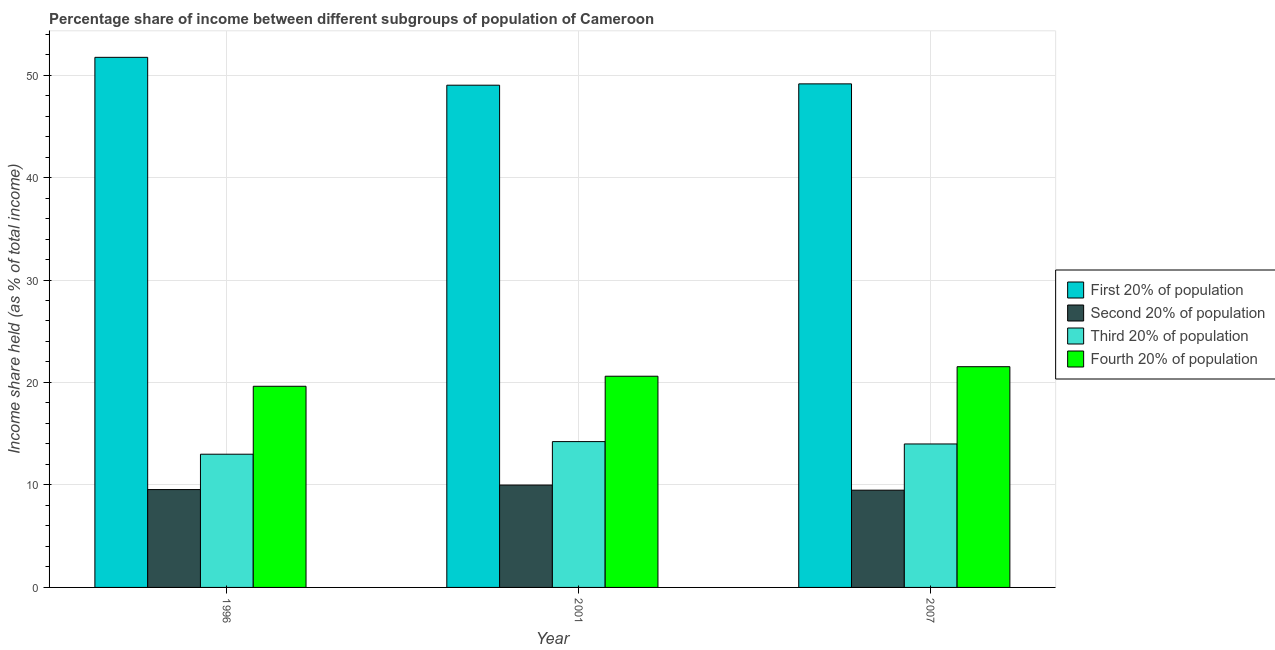How many different coloured bars are there?
Offer a very short reply. 4. Are the number of bars per tick equal to the number of legend labels?
Make the answer very short. Yes. Are the number of bars on each tick of the X-axis equal?
Make the answer very short. Yes. How many bars are there on the 3rd tick from the left?
Your answer should be compact. 4. How many bars are there on the 2nd tick from the right?
Ensure brevity in your answer.  4. What is the share of the income held by second 20% of the population in 2007?
Your response must be concise. 9.49. Across all years, what is the maximum share of the income held by second 20% of the population?
Your response must be concise. 9.99. Across all years, what is the minimum share of the income held by second 20% of the population?
Offer a very short reply. 9.49. What is the total share of the income held by first 20% of the population in the graph?
Ensure brevity in your answer.  149.88. What is the difference between the share of the income held by fourth 20% of the population in 2001 and that in 2007?
Make the answer very short. -0.93. What is the difference between the share of the income held by fourth 20% of the population in 2007 and the share of the income held by first 20% of the population in 2001?
Offer a terse response. 0.93. What is the average share of the income held by second 20% of the population per year?
Provide a succinct answer. 9.68. In the year 2001, what is the difference between the share of the income held by third 20% of the population and share of the income held by fourth 20% of the population?
Make the answer very short. 0. What is the ratio of the share of the income held by first 20% of the population in 1996 to that in 2001?
Make the answer very short. 1.06. What is the difference between the highest and the second highest share of the income held by third 20% of the population?
Offer a very short reply. 0.23. What is the difference between the highest and the lowest share of the income held by second 20% of the population?
Your answer should be compact. 0.5. Is the sum of the share of the income held by fourth 20% of the population in 1996 and 2001 greater than the maximum share of the income held by first 20% of the population across all years?
Give a very brief answer. Yes. Is it the case that in every year, the sum of the share of the income held by second 20% of the population and share of the income held by third 20% of the population is greater than the sum of share of the income held by first 20% of the population and share of the income held by fourth 20% of the population?
Provide a short and direct response. No. What does the 3rd bar from the left in 1996 represents?
Your response must be concise. Third 20% of population. What does the 3rd bar from the right in 2001 represents?
Your response must be concise. Second 20% of population. How many years are there in the graph?
Provide a short and direct response. 3. What is the difference between two consecutive major ticks on the Y-axis?
Your response must be concise. 10. Are the values on the major ticks of Y-axis written in scientific E-notation?
Your answer should be compact. No. Does the graph contain any zero values?
Offer a very short reply. No. How many legend labels are there?
Ensure brevity in your answer.  4. How are the legend labels stacked?
Provide a short and direct response. Vertical. What is the title of the graph?
Give a very brief answer. Percentage share of income between different subgroups of population of Cameroon. Does "Australia" appear as one of the legend labels in the graph?
Ensure brevity in your answer.  No. What is the label or title of the Y-axis?
Ensure brevity in your answer.  Income share held (as % of total income). What is the Income share held (as % of total income) of First 20% of population in 1996?
Keep it short and to the point. 51.73. What is the Income share held (as % of total income) in Second 20% of population in 1996?
Your response must be concise. 9.55. What is the Income share held (as % of total income) of Third 20% of population in 1996?
Your answer should be compact. 13. What is the Income share held (as % of total income) in Fourth 20% of population in 1996?
Ensure brevity in your answer.  19.63. What is the Income share held (as % of total income) in First 20% of population in 2001?
Your answer should be compact. 49.01. What is the Income share held (as % of total income) of Second 20% of population in 2001?
Offer a very short reply. 9.99. What is the Income share held (as % of total income) in Third 20% of population in 2001?
Provide a short and direct response. 14.23. What is the Income share held (as % of total income) of Fourth 20% of population in 2001?
Ensure brevity in your answer.  20.61. What is the Income share held (as % of total income) of First 20% of population in 2007?
Offer a terse response. 49.14. What is the Income share held (as % of total income) in Second 20% of population in 2007?
Offer a very short reply. 9.49. What is the Income share held (as % of total income) of Fourth 20% of population in 2007?
Your answer should be very brief. 21.54. Across all years, what is the maximum Income share held (as % of total income) in First 20% of population?
Make the answer very short. 51.73. Across all years, what is the maximum Income share held (as % of total income) in Second 20% of population?
Your response must be concise. 9.99. Across all years, what is the maximum Income share held (as % of total income) in Third 20% of population?
Your response must be concise. 14.23. Across all years, what is the maximum Income share held (as % of total income) of Fourth 20% of population?
Your response must be concise. 21.54. Across all years, what is the minimum Income share held (as % of total income) in First 20% of population?
Provide a succinct answer. 49.01. Across all years, what is the minimum Income share held (as % of total income) in Second 20% of population?
Make the answer very short. 9.49. Across all years, what is the minimum Income share held (as % of total income) in Third 20% of population?
Provide a succinct answer. 13. Across all years, what is the minimum Income share held (as % of total income) in Fourth 20% of population?
Your answer should be very brief. 19.63. What is the total Income share held (as % of total income) of First 20% of population in the graph?
Ensure brevity in your answer.  149.88. What is the total Income share held (as % of total income) in Second 20% of population in the graph?
Offer a terse response. 29.03. What is the total Income share held (as % of total income) in Third 20% of population in the graph?
Offer a very short reply. 41.23. What is the total Income share held (as % of total income) of Fourth 20% of population in the graph?
Your answer should be very brief. 61.78. What is the difference between the Income share held (as % of total income) of First 20% of population in 1996 and that in 2001?
Offer a terse response. 2.72. What is the difference between the Income share held (as % of total income) in Second 20% of population in 1996 and that in 2001?
Give a very brief answer. -0.44. What is the difference between the Income share held (as % of total income) in Third 20% of population in 1996 and that in 2001?
Offer a terse response. -1.23. What is the difference between the Income share held (as % of total income) of Fourth 20% of population in 1996 and that in 2001?
Your response must be concise. -0.98. What is the difference between the Income share held (as % of total income) in First 20% of population in 1996 and that in 2007?
Ensure brevity in your answer.  2.59. What is the difference between the Income share held (as % of total income) of Second 20% of population in 1996 and that in 2007?
Provide a succinct answer. 0.06. What is the difference between the Income share held (as % of total income) of Fourth 20% of population in 1996 and that in 2007?
Your answer should be very brief. -1.91. What is the difference between the Income share held (as % of total income) in First 20% of population in 2001 and that in 2007?
Offer a terse response. -0.13. What is the difference between the Income share held (as % of total income) of Second 20% of population in 2001 and that in 2007?
Provide a succinct answer. 0.5. What is the difference between the Income share held (as % of total income) of Third 20% of population in 2001 and that in 2007?
Offer a very short reply. 0.23. What is the difference between the Income share held (as % of total income) in Fourth 20% of population in 2001 and that in 2007?
Give a very brief answer. -0.93. What is the difference between the Income share held (as % of total income) of First 20% of population in 1996 and the Income share held (as % of total income) of Second 20% of population in 2001?
Provide a succinct answer. 41.74. What is the difference between the Income share held (as % of total income) of First 20% of population in 1996 and the Income share held (as % of total income) of Third 20% of population in 2001?
Ensure brevity in your answer.  37.5. What is the difference between the Income share held (as % of total income) in First 20% of population in 1996 and the Income share held (as % of total income) in Fourth 20% of population in 2001?
Your response must be concise. 31.12. What is the difference between the Income share held (as % of total income) of Second 20% of population in 1996 and the Income share held (as % of total income) of Third 20% of population in 2001?
Your answer should be very brief. -4.68. What is the difference between the Income share held (as % of total income) of Second 20% of population in 1996 and the Income share held (as % of total income) of Fourth 20% of population in 2001?
Keep it short and to the point. -11.06. What is the difference between the Income share held (as % of total income) of Third 20% of population in 1996 and the Income share held (as % of total income) of Fourth 20% of population in 2001?
Ensure brevity in your answer.  -7.61. What is the difference between the Income share held (as % of total income) in First 20% of population in 1996 and the Income share held (as % of total income) in Second 20% of population in 2007?
Your response must be concise. 42.24. What is the difference between the Income share held (as % of total income) of First 20% of population in 1996 and the Income share held (as % of total income) of Third 20% of population in 2007?
Your response must be concise. 37.73. What is the difference between the Income share held (as % of total income) of First 20% of population in 1996 and the Income share held (as % of total income) of Fourth 20% of population in 2007?
Keep it short and to the point. 30.19. What is the difference between the Income share held (as % of total income) of Second 20% of population in 1996 and the Income share held (as % of total income) of Third 20% of population in 2007?
Your answer should be very brief. -4.45. What is the difference between the Income share held (as % of total income) in Second 20% of population in 1996 and the Income share held (as % of total income) in Fourth 20% of population in 2007?
Offer a very short reply. -11.99. What is the difference between the Income share held (as % of total income) of Third 20% of population in 1996 and the Income share held (as % of total income) of Fourth 20% of population in 2007?
Your answer should be very brief. -8.54. What is the difference between the Income share held (as % of total income) in First 20% of population in 2001 and the Income share held (as % of total income) in Second 20% of population in 2007?
Provide a succinct answer. 39.52. What is the difference between the Income share held (as % of total income) of First 20% of population in 2001 and the Income share held (as % of total income) of Third 20% of population in 2007?
Make the answer very short. 35.01. What is the difference between the Income share held (as % of total income) in First 20% of population in 2001 and the Income share held (as % of total income) in Fourth 20% of population in 2007?
Your response must be concise. 27.47. What is the difference between the Income share held (as % of total income) of Second 20% of population in 2001 and the Income share held (as % of total income) of Third 20% of population in 2007?
Provide a succinct answer. -4.01. What is the difference between the Income share held (as % of total income) in Second 20% of population in 2001 and the Income share held (as % of total income) in Fourth 20% of population in 2007?
Offer a very short reply. -11.55. What is the difference between the Income share held (as % of total income) of Third 20% of population in 2001 and the Income share held (as % of total income) of Fourth 20% of population in 2007?
Offer a terse response. -7.31. What is the average Income share held (as % of total income) of First 20% of population per year?
Provide a short and direct response. 49.96. What is the average Income share held (as % of total income) in Second 20% of population per year?
Keep it short and to the point. 9.68. What is the average Income share held (as % of total income) in Third 20% of population per year?
Keep it short and to the point. 13.74. What is the average Income share held (as % of total income) in Fourth 20% of population per year?
Your response must be concise. 20.59. In the year 1996, what is the difference between the Income share held (as % of total income) of First 20% of population and Income share held (as % of total income) of Second 20% of population?
Give a very brief answer. 42.18. In the year 1996, what is the difference between the Income share held (as % of total income) of First 20% of population and Income share held (as % of total income) of Third 20% of population?
Provide a succinct answer. 38.73. In the year 1996, what is the difference between the Income share held (as % of total income) in First 20% of population and Income share held (as % of total income) in Fourth 20% of population?
Make the answer very short. 32.1. In the year 1996, what is the difference between the Income share held (as % of total income) of Second 20% of population and Income share held (as % of total income) of Third 20% of population?
Your answer should be compact. -3.45. In the year 1996, what is the difference between the Income share held (as % of total income) of Second 20% of population and Income share held (as % of total income) of Fourth 20% of population?
Your response must be concise. -10.08. In the year 1996, what is the difference between the Income share held (as % of total income) in Third 20% of population and Income share held (as % of total income) in Fourth 20% of population?
Offer a terse response. -6.63. In the year 2001, what is the difference between the Income share held (as % of total income) of First 20% of population and Income share held (as % of total income) of Second 20% of population?
Keep it short and to the point. 39.02. In the year 2001, what is the difference between the Income share held (as % of total income) in First 20% of population and Income share held (as % of total income) in Third 20% of population?
Make the answer very short. 34.78. In the year 2001, what is the difference between the Income share held (as % of total income) in First 20% of population and Income share held (as % of total income) in Fourth 20% of population?
Keep it short and to the point. 28.4. In the year 2001, what is the difference between the Income share held (as % of total income) of Second 20% of population and Income share held (as % of total income) of Third 20% of population?
Provide a short and direct response. -4.24. In the year 2001, what is the difference between the Income share held (as % of total income) of Second 20% of population and Income share held (as % of total income) of Fourth 20% of population?
Provide a succinct answer. -10.62. In the year 2001, what is the difference between the Income share held (as % of total income) of Third 20% of population and Income share held (as % of total income) of Fourth 20% of population?
Provide a succinct answer. -6.38. In the year 2007, what is the difference between the Income share held (as % of total income) of First 20% of population and Income share held (as % of total income) of Second 20% of population?
Offer a very short reply. 39.65. In the year 2007, what is the difference between the Income share held (as % of total income) in First 20% of population and Income share held (as % of total income) in Third 20% of population?
Offer a terse response. 35.14. In the year 2007, what is the difference between the Income share held (as % of total income) in First 20% of population and Income share held (as % of total income) in Fourth 20% of population?
Your response must be concise. 27.6. In the year 2007, what is the difference between the Income share held (as % of total income) in Second 20% of population and Income share held (as % of total income) in Third 20% of population?
Your response must be concise. -4.51. In the year 2007, what is the difference between the Income share held (as % of total income) in Second 20% of population and Income share held (as % of total income) in Fourth 20% of population?
Offer a very short reply. -12.05. In the year 2007, what is the difference between the Income share held (as % of total income) of Third 20% of population and Income share held (as % of total income) of Fourth 20% of population?
Provide a short and direct response. -7.54. What is the ratio of the Income share held (as % of total income) of First 20% of population in 1996 to that in 2001?
Your answer should be very brief. 1.06. What is the ratio of the Income share held (as % of total income) of Second 20% of population in 1996 to that in 2001?
Give a very brief answer. 0.96. What is the ratio of the Income share held (as % of total income) in Third 20% of population in 1996 to that in 2001?
Your answer should be very brief. 0.91. What is the ratio of the Income share held (as % of total income) of Fourth 20% of population in 1996 to that in 2001?
Provide a succinct answer. 0.95. What is the ratio of the Income share held (as % of total income) of First 20% of population in 1996 to that in 2007?
Provide a succinct answer. 1.05. What is the ratio of the Income share held (as % of total income) in Fourth 20% of population in 1996 to that in 2007?
Provide a succinct answer. 0.91. What is the ratio of the Income share held (as % of total income) in Second 20% of population in 2001 to that in 2007?
Offer a terse response. 1.05. What is the ratio of the Income share held (as % of total income) of Third 20% of population in 2001 to that in 2007?
Offer a terse response. 1.02. What is the ratio of the Income share held (as % of total income) of Fourth 20% of population in 2001 to that in 2007?
Provide a short and direct response. 0.96. What is the difference between the highest and the second highest Income share held (as % of total income) of First 20% of population?
Keep it short and to the point. 2.59. What is the difference between the highest and the second highest Income share held (as % of total income) in Second 20% of population?
Offer a very short reply. 0.44. What is the difference between the highest and the second highest Income share held (as % of total income) of Third 20% of population?
Your answer should be compact. 0.23. What is the difference between the highest and the second highest Income share held (as % of total income) of Fourth 20% of population?
Your response must be concise. 0.93. What is the difference between the highest and the lowest Income share held (as % of total income) of First 20% of population?
Make the answer very short. 2.72. What is the difference between the highest and the lowest Income share held (as % of total income) of Second 20% of population?
Your response must be concise. 0.5. What is the difference between the highest and the lowest Income share held (as % of total income) of Third 20% of population?
Make the answer very short. 1.23. What is the difference between the highest and the lowest Income share held (as % of total income) of Fourth 20% of population?
Make the answer very short. 1.91. 